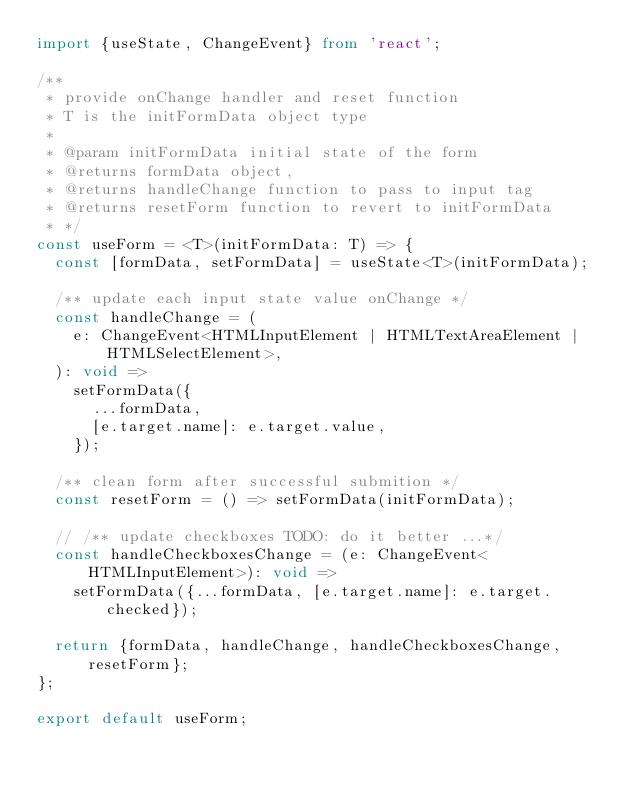<code> <loc_0><loc_0><loc_500><loc_500><_TypeScript_>import {useState, ChangeEvent} from 'react';

/**
 * provide onChange handler and reset function
 * T is the initFormData object type
 *
 * @param initFormData initial state of the form
 * @returns formData object,
 * @returns handleChange function to pass to input tag
 * @returns resetForm function to revert to initFormData
 * */
const useForm = <T>(initFormData: T) => {
  const [formData, setFormData] = useState<T>(initFormData);

  /** update each input state value onChange */
  const handleChange = (
    e: ChangeEvent<HTMLInputElement | HTMLTextAreaElement | HTMLSelectElement>,
  ): void =>
    setFormData({
      ...formData,
      [e.target.name]: e.target.value,
    });

  /** clean form after successful submition */
  const resetForm = () => setFormData(initFormData);

  // /** update checkboxes TODO: do it better ...*/
  const handleCheckboxesChange = (e: ChangeEvent<HTMLInputElement>): void =>
    setFormData({...formData, [e.target.name]: e.target.checked});

  return {formData, handleChange, handleCheckboxesChange, resetForm};
};

export default useForm;
</code> 